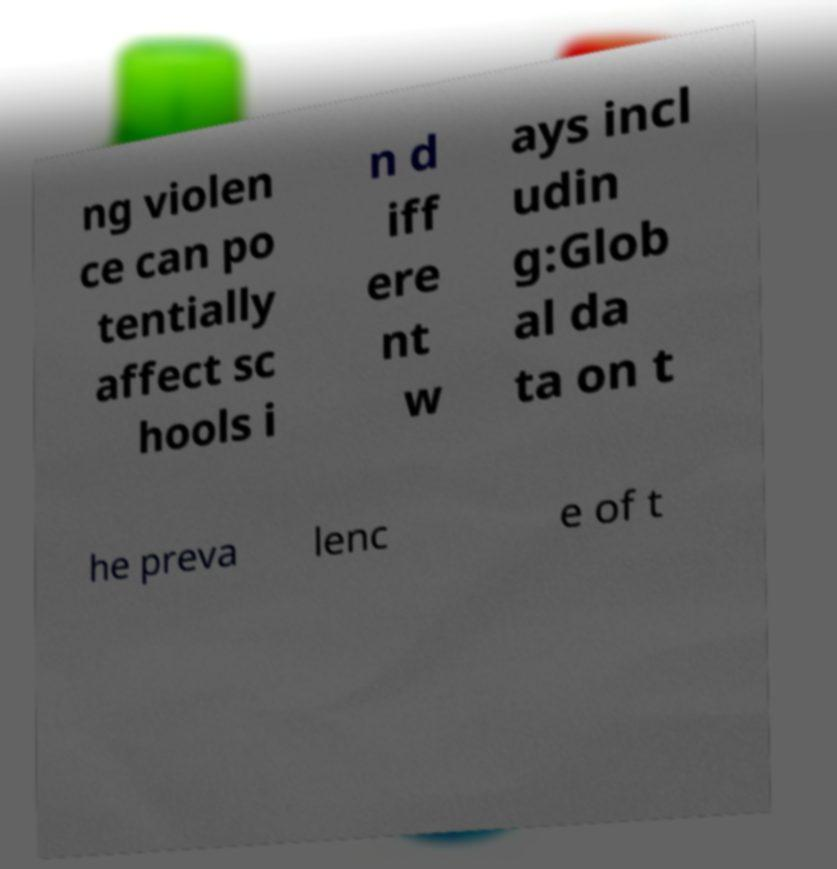I need the written content from this picture converted into text. Can you do that? ng violen ce can po tentially affect sc hools i n d iff ere nt w ays incl udin g:Glob al da ta on t he preva lenc e of t 